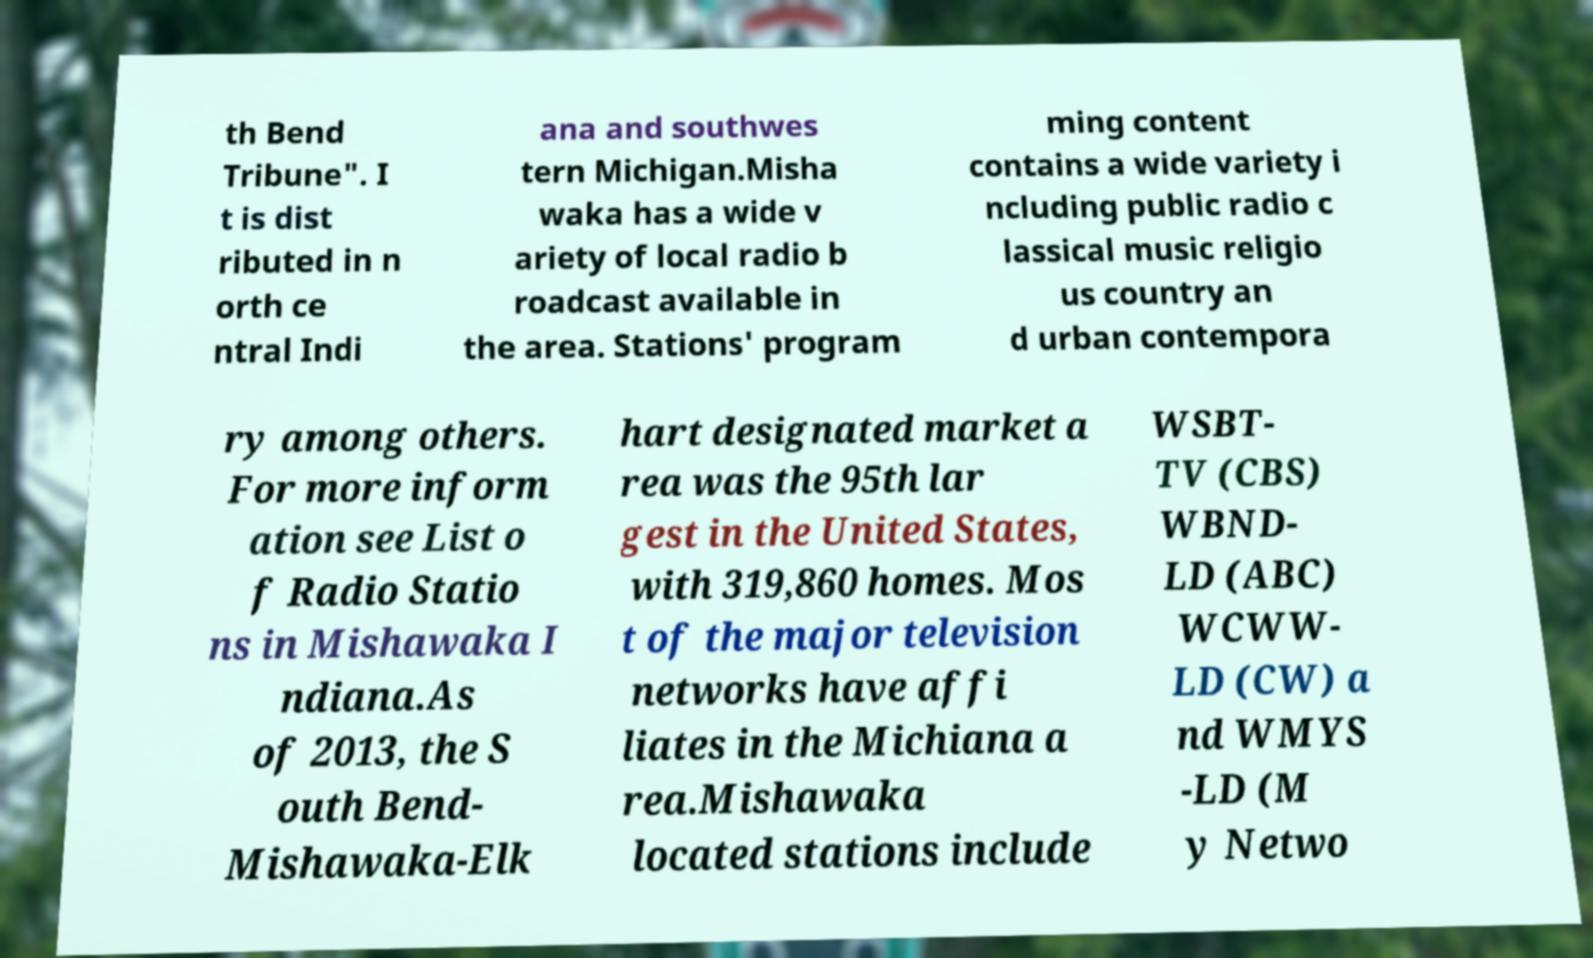For documentation purposes, I need the text within this image transcribed. Could you provide that? th Bend Tribune". I t is dist ributed in n orth ce ntral Indi ana and southwes tern Michigan.Misha waka has a wide v ariety of local radio b roadcast available in the area. Stations' program ming content contains a wide variety i ncluding public radio c lassical music religio us country an d urban contempora ry among others. For more inform ation see List o f Radio Statio ns in Mishawaka I ndiana.As of 2013, the S outh Bend- Mishawaka-Elk hart designated market a rea was the 95th lar gest in the United States, with 319,860 homes. Mos t of the major television networks have affi liates in the Michiana a rea.Mishawaka located stations include WSBT- TV (CBS) WBND- LD (ABC) WCWW- LD (CW) a nd WMYS -LD (M y Netwo 